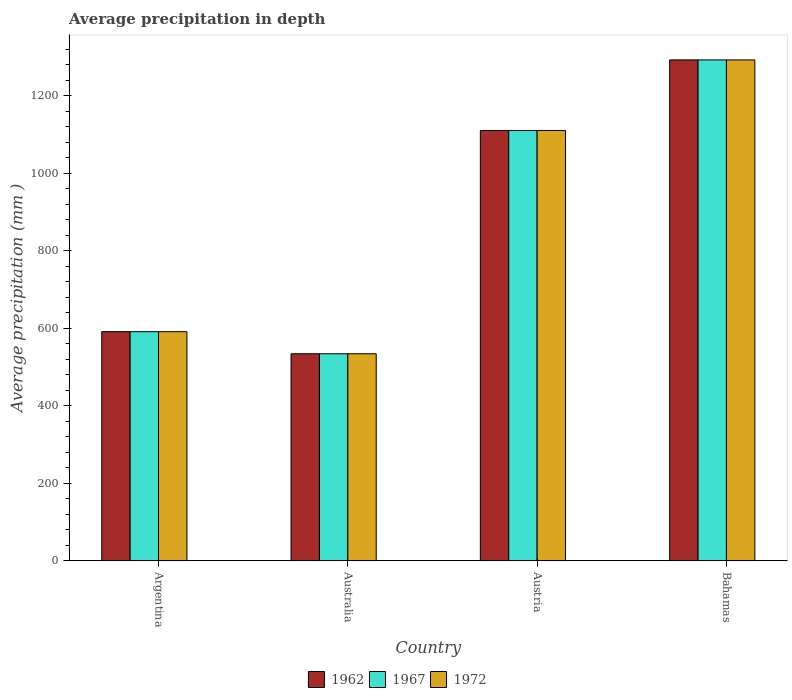How many different coloured bars are there?
Your response must be concise. 3. How many groups of bars are there?
Your response must be concise. 4. Are the number of bars per tick equal to the number of legend labels?
Offer a terse response. Yes. Are the number of bars on each tick of the X-axis equal?
Make the answer very short. Yes. How many bars are there on the 3rd tick from the left?
Ensure brevity in your answer.  3. What is the label of the 4th group of bars from the left?
Ensure brevity in your answer.  Bahamas. In how many cases, is the number of bars for a given country not equal to the number of legend labels?
Ensure brevity in your answer.  0. What is the average precipitation in 1972 in Argentina?
Your response must be concise. 591. Across all countries, what is the maximum average precipitation in 1967?
Keep it short and to the point. 1292. Across all countries, what is the minimum average precipitation in 1967?
Provide a succinct answer. 534. In which country was the average precipitation in 1967 maximum?
Ensure brevity in your answer.  Bahamas. What is the total average precipitation in 1962 in the graph?
Provide a succinct answer. 3527. What is the difference between the average precipitation in 1967 in Argentina and that in Bahamas?
Ensure brevity in your answer.  -701. What is the difference between the average precipitation in 1967 in Austria and the average precipitation in 1972 in Australia?
Ensure brevity in your answer.  576. What is the average average precipitation in 1967 per country?
Your response must be concise. 881.75. What is the difference between the average precipitation of/in 1962 and average precipitation of/in 1967 in Argentina?
Your answer should be very brief. 0. In how many countries, is the average precipitation in 1967 greater than 600 mm?
Your answer should be very brief. 2. What is the ratio of the average precipitation in 1972 in Argentina to that in Australia?
Keep it short and to the point. 1.11. Is the difference between the average precipitation in 1962 in Austria and Bahamas greater than the difference between the average precipitation in 1967 in Austria and Bahamas?
Provide a succinct answer. No. What is the difference between the highest and the second highest average precipitation in 1967?
Your answer should be very brief. 182. What is the difference between the highest and the lowest average precipitation in 1972?
Ensure brevity in your answer.  758. In how many countries, is the average precipitation in 1962 greater than the average average precipitation in 1962 taken over all countries?
Your response must be concise. 2. Is the sum of the average precipitation in 1967 in Australia and Austria greater than the maximum average precipitation in 1962 across all countries?
Your answer should be very brief. Yes. What does the 2nd bar from the left in Austria represents?
Your answer should be compact. 1967. Are all the bars in the graph horizontal?
Keep it short and to the point. No. How many countries are there in the graph?
Your answer should be compact. 4. How many legend labels are there?
Offer a very short reply. 3. How are the legend labels stacked?
Provide a short and direct response. Horizontal. What is the title of the graph?
Offer a terse response. Average precipitation in depth. What is the label or title of the Y-axis?
Offer a terse response. Average precipitation (mm ). What is the Average precipitation (mm ) in 1962 in Argentina?
Provide a succinct answer. 591. What is the Average precipitation (mm ) of 1967 in Argentina?
Provide a succinct answer. 591. What is the Average precipitation (mm ) of 1972 in Argentina?
Offer a very short reply. 591. What is the Average precipitation (mm ) in 1962 in Australia?
Offer a terse response. 534. What is the Average precipitation (mm ) in 1967 in Australia?
Offer a terse response. 534. What is the Average precipitation (mm ) of 1972 in Australia?
Give a very brief answer. 534. What is the Average precipitation (mm ) of 1962 in Austria?
Give a very brief answer. 1110. What is the Average precipitation (mm ) of 1967 in Austria?
Provide a short and direct response. 1110. What is the Average precipitation (mm ) of 1972 in Austria?
Your answer should be very brief. 1110. What is the Average precipitation (mm ) in 1962 in Bahamas?
Offer a very short reply. 1292. What is the Average precipitation (mm ) in 1967 in Bahamas?
Give a very brief answer. 1292. What is the Average precipitation (mm ) of 1972 in Bahamas?
Your answer should be very brief. 1292. Across all countries, what is the maximum Average precipitation (mm ) of 1962?
Provide a succinct answer. 1292. Across all countries, what is the maximum Average precipitation (mm ) in 1967?
Offer a terse response. 1292. Across all countries, what is the maximum Average precipitation (mm ) of 1972?
Your answer should be very brief. 1292. Across all countries, what is the minimum Average precipitation (mm ) of 1962?
Your response must be concise. 534. Across all countries, what is the minimum Average precipitation (mm ) in 1967?
Your response must be concise. 534. Across all countries, what is the minimum Average precipitation (mm ) in 1972?
Your answer should be very brief. 534. What is the total Average precipitation (mm ) in 1962 in the graph?
Ensure brevity in your answer.  3527. What is the total Average precipitation (mm ) of 1967 in the graph?
Give a very brief answer. 3527. What is the total Average precipitation (mm ) in 1972 in the graph?
Your response must be concise. 3527. What is the difference between the Average precipitation (mm ) of 1962 in Argentina and that in Australia?
Keep it short and to the point. 57. What is the difference between the Average precipitation (mm ) of 1972 in Argentina and that in Australia?
Ensure brevity in your answer.  57. What is the difference between the Average precipitation (mm ) of 1962 in Argentina and that in Austria?
Offer a terse response. -519. What is the difference between the Average precipitation (mm ) of 1967 in Argentina and that in Austria?
Offer a very short reply. -519. What is the difference between the Average precipitation (mm ) in 1972 in Argentina and that in Austria?
Offer a very short reply. -519. What is the difference between the Average precipitation (mm ) in 1962 in Argentina and that in Bahamas?
Ensure brevity in your answer.  -701. What is the difference between the Average precipitation (mm ) in 1967 in Argentina and that in Bahamas?
Offer a terse response. -701. What is the difference between the Average precipitation (mm ) in 1972 in Argentina and that in Bahamas?
Provide a succinct answer. -701. What is the difference between the Average precipitation (mm ) of 1962 in Australia and that in Austria?
Make the answer very short. -576. What is the difference between the Average precipitation (mm ) in 1967 in Australia and that in Austria?
Give a very brief answer. -576. What is the difference between the Average precipitation (mm ) in 1972 in Australia and that in Austria?
Provide a succinct answer. -576. What is the difference between the Average precipitation (mm ) of 1962 in Australia and that in Bahamas?
Make the answer very short. -758. What is the difference between the Average precipitation (mm ) in 1967 in Australia and that in Bahamas?
Give a very brief answer. -758. What is the difference between the Average precipitation (mm ) of 1972 in Australia and that in Bahamas?
Your response must be concise. -758. What is the difference between the Average precipitation (mm ) of 1962 in Austria and that in Bahamas?
Your response must be concise. -182. What is the difference between the Average precipitation (mm ) in 1967 in Austria and that in Bahamas?
Ensure brevity in your answer.  -182. What is the difference between the Average precipitation (mm ) of 1972 in Austria and that in Bahamas?
Your answer should be compact. -182. What is the difference between the Average precipitation (mm ) in 1962 in Argentina and the Average precipitation (mm ) in 1972 in Australia?
Make the answer very short. 57. What is the difference between the Average precipitation (mm ) in 1962 in Argentina and the Average precipitation (mm ) in 1967 in Austria?
Offer a very short reply. -519. What is the difference between the Average precipitation (mm ) of 1962 in Argentina and the Average precipitation (mm ) of 1972 in Austria?
Offer a very short reply. -519. What is the difference between the Average precipitation (mm ) of 1967 in Argentina and the Average precipitation (mm ) of 1972 in Austria?
Provide a succinct answer. -519. What is the difference between the Average precipitation (mm ) of 1962 in Argentina and the Average precipitation (mm ) of 1967 in Bahamas?
Offer a very short reply. -701. What is the difference between the Average precipitation (mm ) in 1962 in Argentina and the Average precipitation (mm ) in 1972 in Bahamas?
Your answer should be very brief. -701. What is the difference between the Average precipitation (mm ) in 1967 in Argentina and the Average precipitation (mm ) in 1972 in Bahamas?
Offer a terse response. -701. What is the difference between the Average precipitation (mm ) in 1962 in Australia and the Average precipitation (mm ) in 1967 in Austria?
Provide a short and direct response. -576. What is the difference between the Average precipitation (mm ) of 1962 in Australia and the Average precipitation (mm ) of 1972 in Austria?
Provide a short and direct response. -576. What is the difference between the Average precipitation (mm ) of 1967 in Australia and the Average precipitation (mm ) of 1972 in Austria?
Provide a short and direct response. -576. What is the difference between the Average precipitation (mm ) of 1962 in Australia and the Average precipitation (mm ) of 1967 in Bahamas?
Make the answer very short. -758. What is the difference between the Average precipitation (mm ) in 1962 in Australia and the Average precipitation (mm ) in 1972 in Bahamas?
Offer a terse response. -758. What is the difference between the Average precipitation (mm ) in 1967 in Australia and the Average precipitation (mm ) in 1972 in Bahamas?
Keep it short and to the point. -758. What is the difference between the Average precipitation (mm ) in 1962 in Austria and the Average precipitation (mm ) in 1967 in Bahamas?
Provide a succinct answer. -182. What is the difference between the Average precipitation (mm ) in 1962 in Austria and the Average precipitation (mm ) in 1972 in Bahamas?
Give a very brief answer. -182. What is the difference between the Average precipitation (mm ) of 1967 in Austria and the Average precipitation (mm ) of 1972 in Bahamas?
Your answer should be very brief. -182. What is the average Average precipitation (mm ) of 1962 per country?
Your response must be concise. 881.75. What is the average Average precipitation (mm ) in 1967 per country?
Offer a terse response. 881.75. What is the average Average precipitation (mm ) in 1972 per country?
Ensure brevity in your answer.  881.75. What is the difference between the Average precipitation (mm ) of 1962 and Average precipitation (mm ) of 1967 in Argentina?
Provide a succinct answer. 0. What is the difference between the Average precipitation (mm ) of 1967 and Average precipitation (mm ) of 1972 in Argentina?
Ensure brevity in your answer.  0. What is the difference between the Average precipitation (mm ) in 1962 and Average precipitation (mm ) in 1972 in Australia?
Provide a short and direct response. 0. What is the difference between the Average precipitation (mm ) in 1967 and Average precipitation (mm ) in 1972 in Australia?
Your answer should be compact. 0. What is the difference between the Average precipitation (mm ) in 1962 and Average precipitation (mm ) in 1967 in Austria?
Offer a terse response. 0. What is the difference between the Average precipitation (mm ) in 1967 and Average precipitation (mm ) in 1972 in Austria?
Your answer should be compact. 0. What is the difference between the Average precipitation (mm ) in 1967 and Average precipitation (mm ) in 1972 in Bahamas?
Make the answer very short. 0. What is the ratio of the Average precipitation (mm ) in 1962 in Argentina to that in Australia?
Your answer should be very brief. 1.11. What is the ratio of the Average precipitation (mm ) in 1967 in Argentina to that in Australia?
Make the answer very short. 1.11. What is the ratio of the Average precipitation (mm ) of 1972 in Argentina to that in Australia?
Give a very brief answer. 1.11. What is the ratio of the Average precipitation (mm ) in 1962 in Argentina to that in Austria?
Provide a short and direct response. 0.53. What is the ratio of the Average precipitation (mm ) in 1967 in Argentina to that in Austria?
Offer a very short reply. 0.53. What is the ratio of the Average precipitation (mm ) in 1972 in Argentina to that in Austria?
Keep it short and to the point. 0.53. What is the ratio of the Average precipitation (mm ) in 1962 in Argentina to that in Bahamas?
Your answer should be compact. 0.46. What is the ratio of the Average precipitation (mm ) of 1967 in Argentina to that in Bahamas?
Offer a very short reply. 0.46. What is the ratio of the Average precipitation (mm ) of 1972 in Argentina to that in Bahamas?
Your answer should be compact. 0.46. What is the ratio of the Average precipitation (mm ) in 1962 in Australia to that in Austria?
Provide a succinct answer. 0.48. What is the ratio of the Average precipitation (mm ) in 1967 in Australia to that in Austria?
Give a very brief answer. 0.48. What is the ratio of the Average precipitation (mm ) in 1972 in Australia to that in Austria?
Your answer should be compact. 0.48. What is the ratio of the Average precipitation (mm ) of 1962 in Australia to that in Bahamas?
Keep it short and to the point. 0.41. What is the ratio of the Average precipitation (mm ) in 1967 in Australia to that in Bahamas?
Your response must be concise. 0.41. What is the ratio of the Average precipitation (mm ) of 1972 in Australia to that in Bahamas?
Keep it short and to the point. 0.41. What is the ratio of the Average precipitation (mm ) in 1962 in Austria to that in Bahamas?
Keep it short and to the point. 0.86. What is the ratio of the Average precipitation (mm ) of 1967 in Austria to that in Bahamas?
Your response must be concise. 0.86. What is the ratio of the Average precipitation (mm ) of 1972 in Austria to that in Bahamas?
Offer a terse response. 0.86. What is the difference between the highest and the second highest Average precipitation (mm ) in 1962?
Ensure brevity in your answer.  182. What is the difference between the highest and the second highest Average precipitation (mm ) of 1967?
Keep it short and to the point. 182. What is the difference between the highest and the second highest Average precipitation (mm ) of 1972?
Keep it short and to the point. 182. What is the difference between the highest and the lowest Average precipitation (mm ) in 1962?
Make the answer very short. 758. What is the difference between the highest and the lowest Average precipitation (mm ) in 1967?
Give a very brief answer. 758. What is the difference between the highest and the lowest Average precipitation (mm ) of 1972?
Ensure brevity in your answer.  758. 